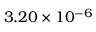<formula> <loc_0><loc_0><loc_500><loc_500>3 . 2 0 \times 1 0 ^ { - 6 }</formula> 